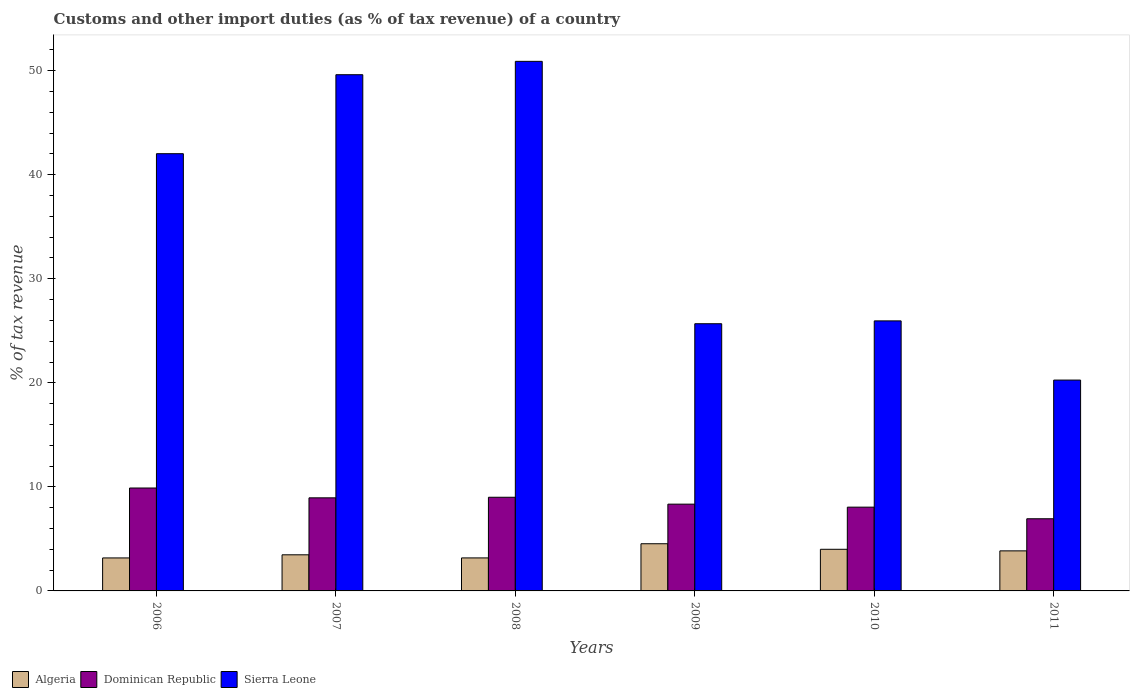How many different coloured bars are there?
Your response must be concise. 3. Are the number of bars on each tick of the X-axis equal?
Your answer should be compact. Yes. In how many cases, is the number of bars for a given year not equal to the number of legend labels?
Your answer should be very brief. 0. What is the percentage of tax revenue from customs in Dominican Republic in 2006?
Give a very brief answer. 9.89. Across all years, what is the maximum percentage of tax revenue from customs in Dominican Republic?
Offer a terse response. 9.89. Across all years, what is the minimum percentage of tax revenue from customs in Sierra Leone?
Provide a short and direct response. 20.27. What is the total percentage of tax revenue from customs in Dominican Republic in the graph?
Offer a very short reply. 51.17. What is the difference between the percentage of tax revenue from customs in Dominican Republic in 2007 and that in 2010?
Offer a terse response. 0.9. What is the difference between the percentage of tax revenue from customs in Algeria in 2011 and the percentage of tax revenue from customs in Sierra Leone in 2010?
Your answer should be very brief. -22.1. What is the average percentage of tax revenue from customs in Dominican Republic per year?
Provide a short and direct response. 8.53. In the year 2010, what is the difference between the percentage of tax revenue from customs in Algeria and percentage of tax revenue from customs in Dominican Republic?
Your answer should be compact. -4.05. In how many years, is the percentage of tax revenue from customs in Algeria greater than 20 %?
Your response must be concise. 0. What is the ratio of the percentage of tax revenue from customs in Algeria in 2007 to that in 2008?
Provide a succinct answer. 1.09. What is the difference between the highest and the second highest percentage of tax revenue from customs in Algeria?
Your response must be concise. 0.53. What is the difference between the highest and the lowest percentage of tax revenue from customs in Algeria?
Your answer should be very brief. 1.36. Is the sum of the percentage of tax revenue from customs in Dominican Republic in 2007 and 2008 greater than the maximum percentage of tax revenue from customs in Sierra Leone across all years?
Your answer should be very brief. No. What does the 3rd bar from the left in 2011 represents?
Provide a succinct answer. Sierra Leone. What does the 2nd bar from the right in 2009 represents?
Provide a short and direct response. Dominican Republic. Is it the case that in every year, the sum of the percentage of tax revenue from customs in Dominican Republic and percentage of tax revenue from customs in Algeria is greater than the percentage of tax revenue from customs in Sierra Leone?
Keep it short and to the point. No. Are all the bars in the graph horizontal?
Your answer should be compact. No. What is the title of the graph?
Ensure brevity in your answer.  Customs and other import duties (as % of tax revenue) of a country. Does "Lithuania" appear as one of the legend labels in the graph?
Make the answer very short. No. What is the label or title of the X-axis?
Provide a short and direct response. Years. What is the label or title of the Y-axis?
Keep it short and to the point. % of tax revenue. What is the % of tax revenue of Algeria in 2006?
Your response must be concise. 3.17. What is the % of tax revenue of Dominican Republic in 2006?
Offer a terse response. 9.89. What is the % of tax revenue in Sierra Leone in 2006?
Keep it short and to the point. 42.02. What is the % of tax revenue in Algeria in 2007?
Offer a terse response. 3.47. What is the % of tax revenue of Dominican Republic in 2007?
Your answer should be very brief. 8.95. What is the % of tax revenue of Sierra Leone in 2007?
Ensure brevity in your answer.  49.61. What is the % of tax revenue in Algeria in 2008?
Your response must be concise. 3.17. What is the % of tax revenue in Dominican Republic in 2008?
Your response must be concise. 9. What is the % of tax revenue in Sierra Leone in 2008?
Offer a terse response. 50.9. What is the % of tax revenue in Algeria in 2009?
Your answer should be very brief. 4.53. What is the % of tax revenue of Dominican Republic in 2009?
Make the answer very short. 8.34. What is the % of tax revenue of Sierra Leone in 2009?
Provide a succinct answer. 25.68. What is the % of tax revenue in Algeria in 2010?
Keep it short and to the point. 4. What is the % of tax revenue in Dominican Republic in 2010?
Keep it short and to the point. 8.05. What is the % of tax revenue in Sierra Leone in 2010?
Offer a terse response. 25.95. What is the % of tax revenue in Algeria in 2011?
Give a very brief answer. 3.85. What is the % of tax revenue of Dominican Republic in 2011?
Your response must be concise. 6.94. What is the % of tax revenue in Sierra Leone in 2011?
Your response must be concise. 20.27. Across all years, what is the maximum % of tax revenue of Algeria?
Offer a very short reply. 4.53. Across all years, what is the maximum % of tax revenue in Dominican Republic?
Offer a terse response. 9.89. Across all years, what is the maximum % of tax revenue of Sierra Leone?
Give a very brief answer. 50.9. Across all years, what is the minimum % of tax revenue of Algeria?
Provide a succinct answer. 3.17. Across all years, what is the minimum % of tax revenue in Dominican Republic?
Offer a very short reply. 6.94. Across all years, what is the minimum % of tax revenue of Sierra Leone?
Provide a short and direct response. 20.27. What is the total % of tax revenue in Algeria in the graph?
Your answer should be very brief. 22.2. What is the total % of tax revenue of Dominican Republic in the graph?
Provide a short and direct response. 51.17. What is the total % of tax revenue in Sierra Leone in the graph?
Your answer should be very brief. 214.44. What is the difference between the % of tax revenue in Algeria in 2006 and that in 2007?
Give a very brief answer. -0.3. What is the difference between the % of tax revenue in Dominican Republic in 2006 and that in 2007?
Give a very brief answer. 0.94. What is the difference between the % of tax revenue of Sierra Leone in 2006 and that in 2007?
Your answer should be compact. -7.59. What is the difference between the % of tax revenue of Algeria in 2006 and that in 2008?
Ensure brevity in your answer.  -0. What is the difference between the % of tax revenue of Dominican Republic in 2006 and that in 2008?
Give a very brief answer. 0.89. What is the difference between the % of tax revenue in Sierra Leone in 2006 and that in 2008?
Provide a succinct answer. -8.87. What is the difference between the % of tax revenue of Algeria in 2006 and that in 2009?
Keep it short and to the point. -1.36. What is the difference between the % of tax revenue in Dominican Republic in 2006 and that in 2009?
Your answer should be compact. 1.55. What is the difference between the % of tax revenue in Sierra Leone in 2006 and that in 2009?
Give a very brief answer. 16.34. What is the difference between the % of tax revenue of Algeria in 2006 and that in 2010?
Ensure brevity in your answer.  -0.83. What is the difference between the % of tax revenue of Dominican Republic in 2006 and that in 2010?
Keep it short and to the point. 1.84. What is the difference between the % of tax revenue in Sierra Leone in 2006 and that in 2010?
Provide a short and direct response. 16.07. What is the difference between the % of tax revenue in Algeria in 2006 and that in 2011?
Your response must be concise. -0.68. What is the difference between the % of tax revenue of Dominican Republic in 2006 and that in 2011?
Make the answer very short. 2.96. What is the difference between the % of tax revenue in Sierra Leone in 2006 and that in 2011?
Provide a short and direct response. 21.76. What is the difference between the % of tax revenue in Algeria in 2007 and that in 2008?
Your answer should be compact. 0.3. What is the difference between the % of tax revenue in Dominican Republic in 2007 and that in 2008?
Offer a very short reply. -0.05. What is the difference between the % of tax revenue in Sierra Leone in 2007 and that in 2008?
Provide a succinct answer. -1.28. What is the difference between the % of tax revenue of Algeria in 2007 and that in 2009?
Your answer should be very brief. -1.06. What is the difference between the % of tax revenue of Dominican Republic in 2007 and that in 2009?
Provide a short and direct response. 0.61. What is the difference between the % of tax revenue in Sierra Leone in 2007 and that in 2009?
Provide a succinct answer. 23.93. What is the difference between the % of tax revenue in Algeria in 2007 and that in 2010?
Give a very brief answer. -0.53. What is the difference between the % of tax revenue of Dominican Republic in 2007 and that in 2010?
Keep it short and to the point. 0.9. What is the difference between the % of tax revenue in Sierra Leone in 2007 and that in 2010?
Your answer should be very brief. 23.66. What is the difference between the % of tax revenue of Algeria in 2007 and that in 2011?
Offer a terse response. -0.38. What is the difference between the % of tax revenue of Dominican Republic in 2007 and that in 2011?
Keep it short and to the point. 2.01. What is the difference between the % of tax revenue of Sierra Leone in 2007 and that in 2011?
Your answer should be very brief. 29.35. What is the difference between the % of tax revenue in Algeria in 2008 and that in 2009?
Provide a short and direct response. -1.36. What is the difference between the % of tax revenue of Dominican Republic in 2008 and that in 2009?
Your response must be concise. 0.66. What is the difference between the % of tax revenue in Sierra Leone in 2008 and that in 2009?
Your answer should be very brief. 25.22. What is the difference between the % of tax revenue in Algeria in 2008 and that in 2010?
Make the answer very short. -0.83. What is the difference between the % of tax revenue in Dominican Republic in 2008 and that in 2010?
Keep it short and to the point. 0.95. What is the difference between the % of tax revenue in Sierra Leone in 2008 and that in 2010?
Offer a terse response. 24.94. What is the difference between the % of tax revenue of Algeria in 2008 and that in 2011?
Ensure brevity in your answer.  -0.68. What is the difference between the % of tax revenue in Dominican Republic in 2008 and that in 2011?
Your answer should be very brief. 2.07. What is the difference between the % of tax revenue in Sierra Leone in 2008 and that in 2011?
Your answer should be compact. 30.63. What is the difference between the % of tax revenue of Algeria in 2009 and that in 2010?
Provide a succinct answer. 0.53. What is the difference between the % of tax revenue in Dominican Republic in 2009 and that in 2010?
Provide a succinct answer. 0.29. What is the difference between the % of tax revenue in Sierra Leone in 2009 and that in 2010?
Keep it short and to the point. -0.27. What is the difference between the % of tax revenue in Algeria in 2009 and that in 2011?
Keep it short and to the point. 0.68. What is the difference between the % of tax revenue in Dominican Republic in 2009 and that in 2011?
Your answer should be compact. 1.4. What is the difference between the % of tax revenue in Sierra Leone in 2009 and that in 2011?
Your response must be concise. 5.42. What is the difference between the % of tax revenue in Algeria in 2010 and that in 2011?
Give a very brief answer. 0.15. What is the difference between the % of tax revenue of Dominican Republic in 2010 and that in 2011?
Ensure brevity in your answer.  1.12. What is the difference between the % of tax revenue of Sierra Leone in 2010 and that in 2011?
Provide a short and direct response. 5.69. What is the difference between the % of tax revenue in Algeria in 2006 and the % of tax revenue in Dominican Republic in 2007?
Your response must be concise. -5.78. What is the difference between the % of tax revenue of Algeria in 2006 and the % of tax revenue of Sierra Leone in 2007?
Give a very brief answer. -46.44. What is the difference between the % of tax revenue of Dominican Republic in 2006 and the % of tax revenue of Sierra Leone in 2007?
Keep it short and to the point. -39.72. What is the difference between the % of tax revenue in Algeria in 2006 and the % of tax revenue in Dominican Republic in 2008?
Offer a very short reply. -5.83. What is the difference between the % of tax revenue of Algeria in 2006 and the % of tax revenue of Sierra Leone in 2008?
Offer a terse response. -47.73. What is the difference between the % of tax revenue of Dominican Republic in 2006 and the % of tax revenue of Sierra Leone in 2008?
Give a very brief answer. -41.01. What is the difference between the % of tax revenue of Algeria in 2006 and the % of tax revenue of Dominican Republic in 2009?
Your response must be concise. -5.17. What is the difference between the % of tax revenue in Algeria in 2006 and the % of tax revenue in Sierra Leone in 2009?
Provide a short and direct response. -22.51. What is the difference between the % of tax revenue of Dominican Republic in 2006 and the % of tax revenue of Sierra Leone in 2009?
Ensure brevity in your answer.  -15.79. What is the difference between the % of tax revenue in Algeria in 2006 and the % of tax revenue in Dominican Republic in 2010?
Your answer should be very brief. -4.88. What is the difference between the % of tax revenue in Algeria in 2006 and the % of tax revenue in Sierra Leone in 2010?
Your answer should be compact. -22.78. What is the difference between the % of tax revenue in Dominican Republic in 2006 and the % of tax revenue in Sierra Leone in 2010?
Your response must be concise. -16.06. What is the difference between the % of tax revenue in Algeria in 2006 and the % of tax revenue in Dominican Republic in 2011?
Provide a succinct answer. -3.76. What is the difference between the % of tax revenue in Algeria in 2006 and the % of tax revenue in Sierra Leone in 2011?
Provide a short and direct response. -17.09. What is the difference between the % of tax revenue of Dominican Republic in 2006 and the % of tax revenue of Sierra Leone in 2011?
Your answer should be very brief. -10.37. What is the difference between the % of tax revenue of Algeria in 2007 and the % of tax revenue of Dominican Republic in 2008?
Ensure brevity in your answer.  -5.53. What is the difference between the % of tax revenue in Algeria in 2007 and the % of tax revenue in Sierra Leone in 2008?
Provide a short and direct response. -47.43. What is the difference between the % of tax revenue in Dominican Republic in 2007 and the % of tax revenue in Sierra Leone in 2008?
Offer a terse response. -41.95. What is the difference between the % of tax revenue of Algeria in 2007 and the % of tax revenue of Dominican Republic in 2009?
Your answer should be compact. -4.87. What is the difference between the % of tax revenue in Algeria in 2007 and the % of tax revenue in Sierra Leone in 2009?
Provide a succinct answer. -22.21. What is the difference between the % of tax revenue of Dominican Republic in 2007 and the % of tax revenue of Sierra Leone in 2009?
Your answer should be very brief. -16.73. What is the difference between the % of tax revenue of Algeria in 2007 and the % of tax revenue of Dominican Republic in 2010?
Your answer should be compact. -4.58. What is the difference between the % of tax revenue of Algeria in 2007 and the % of tax revenue of Sierra Leone in 2010?
Your answer should be compact. -22.48. What is the difference between the % of tax revenue of Dominican Republic in 2007 and the % of tax revenue of Sierra Leone in 2010?
Give a very brief answer. -17.01. What is the difference between the % of tax revenue of Algeria in 2007 and the % of tax revenue of Dominican Republic in 2011?
Your answer should be very brief. -3.46. What is the difference between the % of tax revenue of Algeria in 2007 and the % of tax revenue of Sierra Leone in 2011?
Provide a succinct answer. -16.79. What is the difference between the % of tax revenue in Dominican Republic in 2007 and the % of tax revenue in Sierra Leone in 2011?
Your response must be concise. -11.32. What is the difference between the % of tax revenue of Algeria in 2008 and the % of tax revenue of Dominican Republic in 2009?
Make the answer very short. -5.17. What is the difference between the % of tax revenue in Algeria in 2008 and the % of tax revenue in Sierra Leone in 2009?
Give a very brief answer. -22.51. What is the difference between the % of tax revenue in Dominican Republic in 2008 and the % of tax revenue in Sierra Leone in 2009?
Make the answer very short. -16.68. What is the difference between the % of tax revenue in Algeria in 2008 and the % of tax revenue in Dominican Republic in 2010?
Offer a very short reply. -4.88. What is the difference between the % of tax revenue in Algeria in 2008 and the % of tax revenue in Sierra Leone in 2010?
Provide a succinct answer. -22.78. What is the difference between the % of tax revenue in Dominican Republic in 2008 and the % of tax revenue in Sierra Leone in 2010?
Your answer should be compact. -16.95. What is the difference between the % of tax revenue of Algeria in 2008 and the % of tax revenue of Dominican Republic in 2011?
Offer a very short reply. -3.76. What is the difference between the % of tax revenue in Algeria in 2008 and the % of tax revenue in Sierra Leone in 2011?
Offer a very short reply. -17.09. What is the difference between the % of tax revenue of Dominican Republic in 2008 and the % of tax revenue of Sierra Leone in 2011?
Your answer should be compact. -11.26. What is the difference between the % of tax revenue of Algeria in 2009 and the % of tax revenue of Dominican Republic in 2010?
Provide a succinct answer. -3.52. What is the difference between the % of tax revenue in Algeria in 2009 and the % of tax revenue in Sierra Leone in 2010?
Your answer should be very brief. -21.42. What is the difference between the % of tax revenue of Dominican Republic in 2009 and the % of tax revenue of Sierra Leone in 2010?
Offer a terse response. -17.62. What is the difference between the % of tax revenue in Algeria in 2009 and the % of tax revenue in Dominican Republic in 2011?
Keep it short and to the point. -2.4. What is the difference between the % of tax revenue in Algeria in 2009 and the % of tax revenue in Sierra Leone in 2011?
Offer a terse response. -15.73. What is the difference between the % of tax revenue in Dominican Republic in 2009 and the % of tax revenue in Sierra Leone in 2011?
Your response must be concise. -11.93. What is the difference between the % of tax revenue of Algeria in 2010 and the % of tax revenue of Dominican Republic in 2011?
Ensure brevity in your answer.  -2.93. What is the difference between the % of tax revenue in Algeria in 2010 and the % of tax revenue in Sierra Leone in 2011?
Provide a short and direct response. -16.26. What is the difference between the % of tax revenue in Dominican Republic in 2010 and the % of tax revenue in Sierra Leone in 2011?
Your response must be concise. -12.21. What is the average % of tax revenue in Algeria per year?
Ensure brevity in your answer.  3.7. What is the average % of tax revenue of Dominican Republic per year?
Provide a short and direct response. 8.53. What is the average % of tax revenue in Sierra Leone per year?
Your answer should be compact. 35.74. In the year 2006, what is the difference between the % of tax revenue of Algeria and % of tax revenue of Dominican Republic?
Your response must be concise. -6.72. In the year 2006, what is the difference between the % of tax revenue in Algeria and % of tax revenue in Sierra Leone?
Keep it short and to the point. -38.85. In the year 2006, what is the difference between the % of tax revenue of Dominican Republic and % of tax revenue of Sierra Leone?
Keep it short and to the point. -32.13. In the year 2007, what is the difference between the % of tax revenue in Algeria and % of tax revenue in Dominican Republic?
Keep it short and to the point. -5.48. In the year 2007, what is the difference between the % of tax revenue of Algeria and % of tax revenue of Sierra Leone?
Offer a very short reply. -46.14. In the year 2007, what is the difference between the % of tax revenue of Dominican Republic and % of tax revenue of Sierra Leone?
Your answer should be compact. -40.67. In the year 2008, what is the difference between the % of tax revenue of Algeria and % of tax revenue of Dominican Republic?
Your response must be concise. -5.83. In the year 2008, what is the difference between the % of tax revenue in Algeria and % of tax revenue in Sierra Leone?
Your answer should be very brief. -47.73. In the year 2008, what is the difference between the % of tax revenue in Dominican Republic and % of tax revenue in Sierra Leone?
Provide a short and direct response. -41.9. In the year 2009, what is the difference between the % of tax revenue of Algeria and % of tax revenue of Dominican Republic?
Your answer should be very brief. -3.81. In the year 2009, what is the difference between the % of tax revenue of Algeria and % of tax revenue of Sierra Leone?
Provide a short and direct response. -21.15. In the year 2009, what is the difference between the % of tax revenue in Dominican Republic and % of tax revenue in Sierra Leone?
Ensure brevity in your answer.  -17.34. In the year 2010, what is the difference between the % of tax revenue of Algeria and % of tax revenue of Dominican Republic?
Your answer should be compact. -4.05. In the year 2010, what is the difference between the % of tax revenue of Algeria and % of tax revenue of Sierra Leone?
Give a very brief answer. -21.95. In the year 2010, what is the difference between the % of tax revenue of Dominican Republic and % of tax revenue of Sierra Leone?
Your answer should be very brief. -17.9. In the year 2011, what is the difference between the % of tax revenue of Algeria and % of tax revenue of Dominican Republic?
Provide a succinct answer. -3.09. In the year 2011, what is the difference between the % of tax revenue in Algeria and % of tax revenue in Sierra Leone?
Your response must be concise. -16.42. In the year 2011, what is the difference between the % of tax revenue of Dominican Republic and % of tax revenue of Sierra Leone?
Provide a short and direct response. -13.33. What is the ratio of the % of tax revenue of Algeria in 2006 to that in 2007?
Provide a short and direct response. 0.91. What is the ratio of the % of tax revenue in Dominican Republic in 2006 to that in 2007?
Your answer should be compact. 1.11. What is the ratio of the % of tax revenue in Sierra Leone in 2006 to that in 2007?
Offer a very short reply. 0.85. What is the ratio of the % of tax revenue of Algeria in 2006 to that in 2008?
Keep it short and to the point. 1. What is the ratio of the % of tax revenue of Dominican Republic in 2006 to that in 2008?
Offer a very short reply. 1.1. What is the ratio of the % of tax revenue in Sierra Leone in 2006 to that in 2008?
Your answer should be compact. 0.83. What is the ratio of the % of tax revenue in Algeria in 2006 to that in 2009?
Your response must be concise. 0.7. What is the ratio of the % of tax revenue in Dominican Republic in 2006 to that in 2009?
Offer a terse response. 1.19. What is the ratio of the % of tax revenue of Sierra Leone in 2006 to that in 2009?
Offer a very short reply. 1.64. What is the ratio of the % of tax revenue in Algeria in 2006 to that in 2010?
Keep it short and to the point. 0.79. What is the ratio of the % of tax revenue of Dominican Republic in 2006 to that in 2010?
Your response must be concise. 1.23. What is the ratio of the % of tax revenue in Sierra Leone in 2006 to that in 2010?
Your answer should be very brief. 1.62. What is the ratio of the % of tax revenue in Algeria in 2006 to that in 2011?
Your response must be concise. 0.82. What is the ratio of the % of tax revenue of Dominican Republic in 2006 to that in 2011?
Offer a terse response. 1.43. What is the ratio of the % of tax revenue in Sierra Leone in 2006 to that in 2011?
Your answer should be very brief. 2.07. What is the ratio of the % of tax revenue in Algeria in 2007 to that in 2008?
Your answer should be compact. 1.09. What is the ratio of the % of tax revenue in Dominican Republic in 2007 to that in 2008?
Your answer should be very brief. 0.99. What is the ratio of the % of tax revenue of Sierra Leone in 2007 to that in 2008?
Provide a short and direct response. 0.97. What is the ratio of the % of tax revenue of Algeria in 2007 to that in 2009?
Make the answer very short. 0.77. What is the ratio of the % of tax revenue in Dominican Republic in 2007 to that in 2009?
Give a very brief answer. 1.07. What is the ratio of the % of tax revenue of Sierra Leone in 2007 to that in 2009?
Offer a very short reply. 1.93. What is the ratio of the % of tax revenue in Algeria in 2007 to that in 2010?
Your answer should be very brief. 0.87. What is the ratio of the % of tax revenue in Dominican Republic in 2007 to that in 2010?
Provide a short and direct response. 1.11. What is the ratio of the % of tax revenue in Sierra Leone in 2007 to that in 2010?
Your answer should be very brief. 1.91. What is the ratio of the % of tax revenue in Algeria in 2007 to that in 2011?
Give a very brief answer. 0.9. What is the ratio of the % of tax revenue in Dominican Republic in 2007 to that in 2011?
Ensure brevity in your answer.  1.29. What is the ratio of the % of tax revenue in Sierra Leone in 2007 to that in 2011?
Keep it short and to the point. 2.45. What is the ratio of the % of tax revenue of Algeria in 2008 to that in 2009?
Provide a short and direct response. 0.7. What is the ratio of the % of tax revenue in Dominican Republic in 2008 to that in 2009?
Your response must be concise. 1.08. What is the ratio of the % of tax revenue in Sierra Leone in 2008 to that in 2009?
Ensure brevity in your answer.  1.98. What is the ratio of the % of tax revenue in Algeria in 2008 to that in 2010?
Your answer should be very brief. 0.79. What is the ratio of the % of tax revenue of Dominican Republic in 2008 to that in 2010?
Your answer should be compact. 1.12. What is the ratio of the % of tax revenue in Sierra Leone in 2008 to that in 2010?
Ensure brevity in your answer.  1.96. What is the ratio of the % of tax revenue of Algeria in 2008 to that in 2011?
Offer a terse response. 0.82. What is the ratio of the % of tax revenue in Dominican Republic in 2008 to that in 2011?
Provide a short and direct response. 1.3. What is the ratio of the % of tax revenue of Sierra Leone in 2008 to that in 2011?
Offer a terse response. 2.51. What is the ratio of the % of tax revenue of Algeria in 2009 to that in 2010?
Make the answer very short. 1.13. What is the ratio of the % of tax revenue in Dominican Republic in 2009 to that in 2010?
Provide a short and direct response. 1.04. What is the ratio of the % of tax revenue of Algeria in 2009 to that in 2011?
Your response must be concise. 1.18. What is the ratio of the % of tax revenue in Dominican Republic in 2009 to that in 2011?
Keep it short and to the point. 1.2. What is the ratio of the % of tax revenue of Sierra Leone in 2009 to that in 2011?
Give a very brief answer. 1.27. What is the ratio of the % of tax revenue in Algeria in 2010 to that in 2011?
Provide a succinct answer. 1.04. What is the ratio of the % of tax revenue of Dominican Republic in 2010 to that in 2011?
Your response must be concise. 1.16. What is the ratio of the % of tax revenue of Sierra Leone in 2010 to that in 2011?
Make the answer very short. 1.28. What is the difference between the highest and the second highest % of tax revenue in Algeria?
Give a very brief answer. 0.53. What is the difference between the highest and the second highest % of tax revenue in Dominican Republic?
Your response must be concise. 0.89. What is the difference between the highest and the second highest % of tax revenue in Sierra Leone?
Provide a short and direct response. 1.28. What is the difference between the highest and the lowest % of tax revenue in Algeria?
Make the answer very short. 1.36. What is the difference between the highest and the lowest % of tax revenue in Dominican Republic?
Provide a succinct answer. 2.96. What is the difference between the highest and the lowest % of tax revenue of Sierra Leone?
Provide a short and direct response. 30.63. 